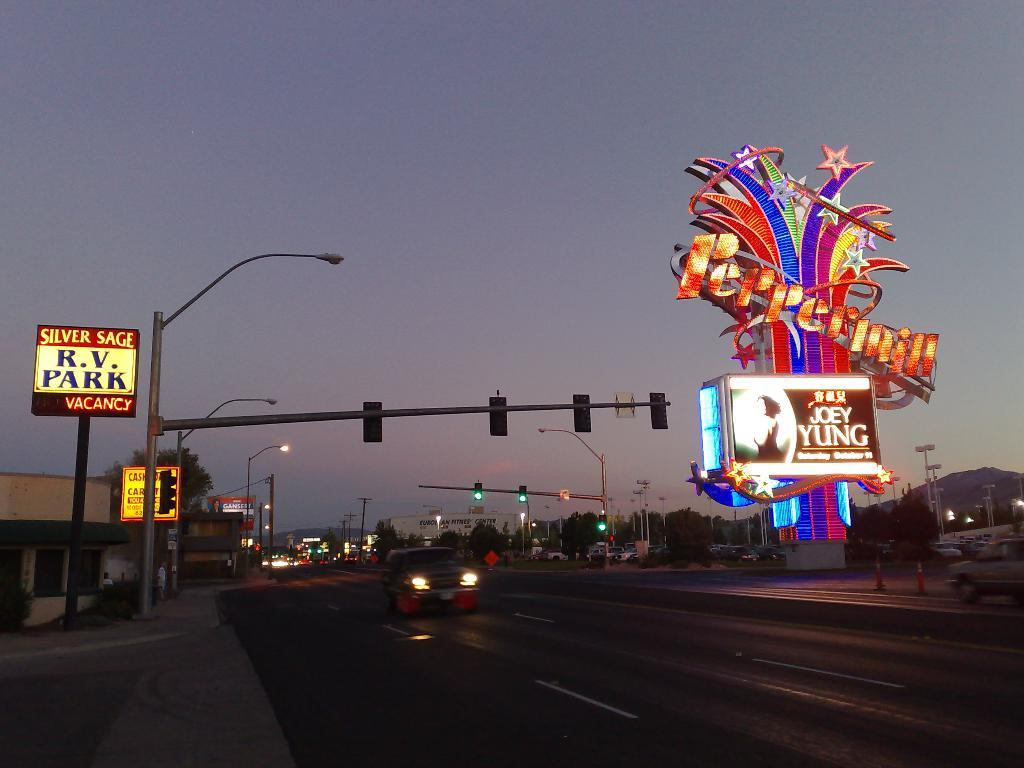<image>
Offer a succinct explanation of the picture presented. Car riding on a street in the evening along is a R.V. Park sign and a sign saying Joey Yung for a concert. 